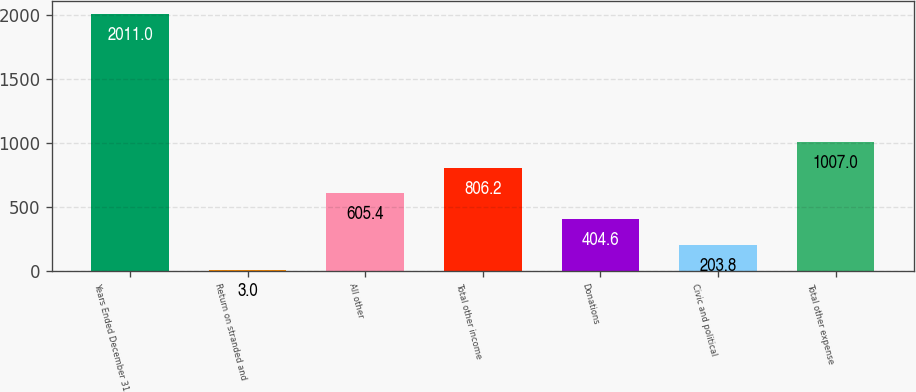Convert chart. <chart><loc_0><loc_0><loc_500><loc_500><bar_chart><fcel>Years Ended December 31<fcel>Return on stranded and<fcel>All other<fcel>Total other income<fcel>Donations<fcel>Civic and political<fcel>Total other expense<nl><fcel>2011<fcel>3<fcel>605.4<fcel>806.2<fcel>404.6<fcel>203.8<fcel>1007<nl></chart> 